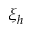Convert formula to latex. <formula><loc_0><loc_0><loc_500><loc_500>\xi _ { h }</formula> 